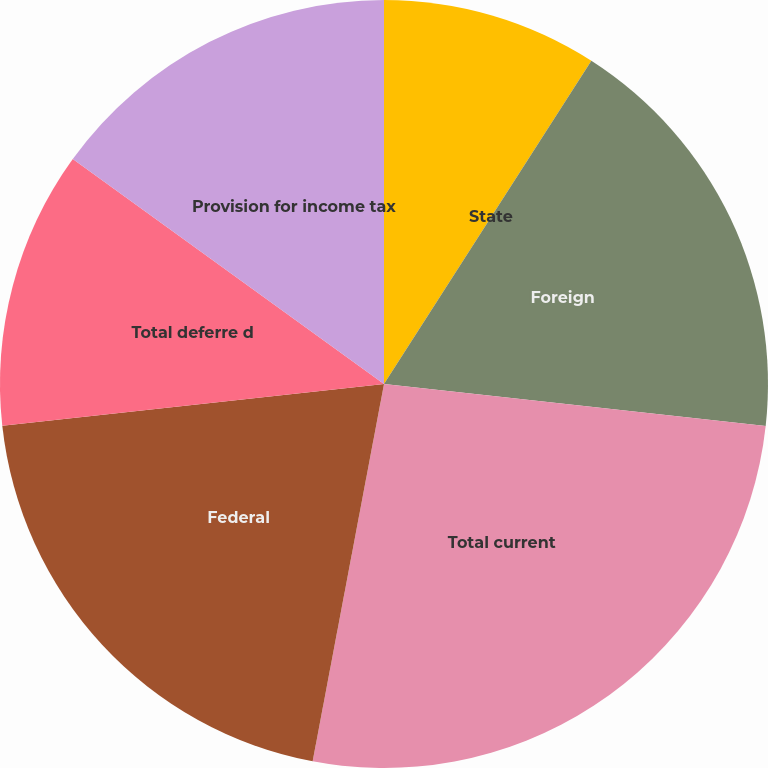Convert chart. <chart><loc_0><loc_0><loc_500><loc_500><pie_chart><fcel>Federal tax<fcel>State<fcel>Foreign<fcel>Total current<fcel>Federal<fcel>Total deferre d<fcel>Provision for income tax<nl><fcel>9.08%<fcel>0.0%<fcel>17.67%<fcel>26.23%<fcel>20.29%<fcel>11.7%<fcel>15.04%<nl></chart> 